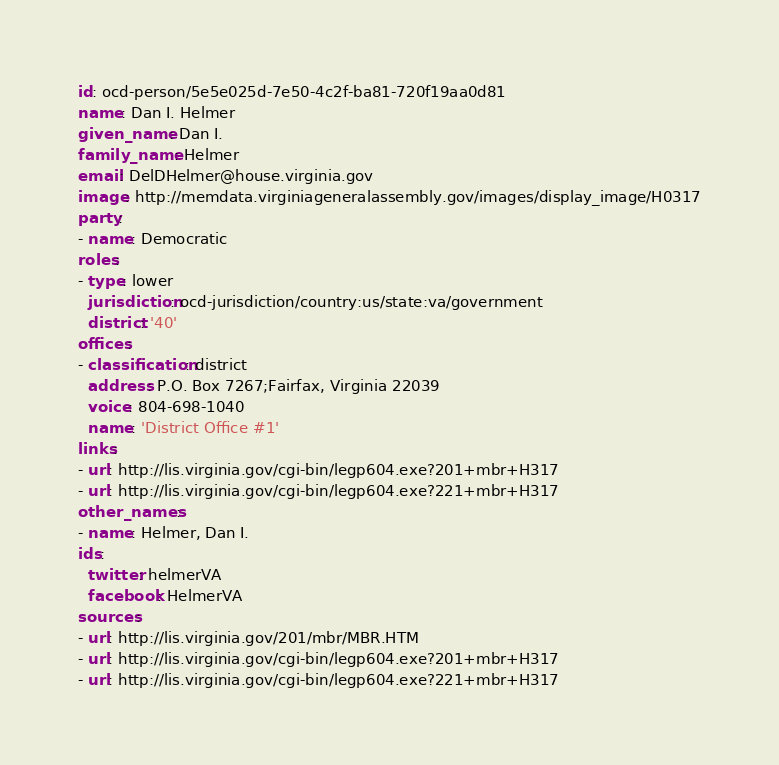Convert code to text. <code><loc_0><loc_0><loc_500><loc_500><_YAML_>id: ocd-person/5e5e025d-7e50-4c2f-ba81-720f19aa0d81
name: Dan I. Helmer
given_name: Dan I.
family_name: Helmer
email: DelDHelmer@house.virginia.gov
image: http://memdata.virginiageneralassembly.gov/images/display_image/H0317
party:
- name: Democratic
roles:
- type: lower
  jurisdiction: ocd-jurisdiction/country:us/state:va/government
  district: '40'
offices:
- classification: district
  address: P.O. Box 7267;Fairfax, Virginia 22039
  voice: 804-698-1040
  name: 'District Office #1'
links:
- url: http://lis.virginia.gov/cgi-bin/legp604.exe?201+mbr+H317
- url: http://lis.virginia.gov/cgi-bin/legp604.exe?221+mbr+H317
other_names:
- name: Helmer, Dan I.
ids:
  twitter: helmerVA
  facebook: HelmerVA
sources:
- url: http://lis.virginia.gov/201/mbr/MBR.HTM
- url: http://lis.virginia.gov/cgi-bin/legp604.exe?201+mbr+H317
- url: http://lis.virginia.gov/cgi-bin/legp604.exe?221+mbr+H317
</code> 